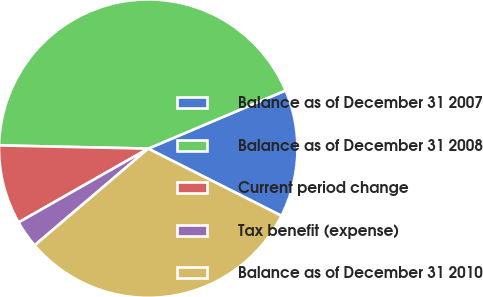Convert chart. <chart><loc_0><loc_0><loc_500><loc_500><pie_chart><fcel>Balance as of December 31 2007<fcel>Balance as of December 31 2008<fcel>Current period change<fcel>Tax benefit (expense)<fcel>Balance as of December 31 2010<nl><fcel>13.81%<fcel>43.28%<fcel>8.58%<fcel>2.99%<fcel>31.34%<nl></chart> 